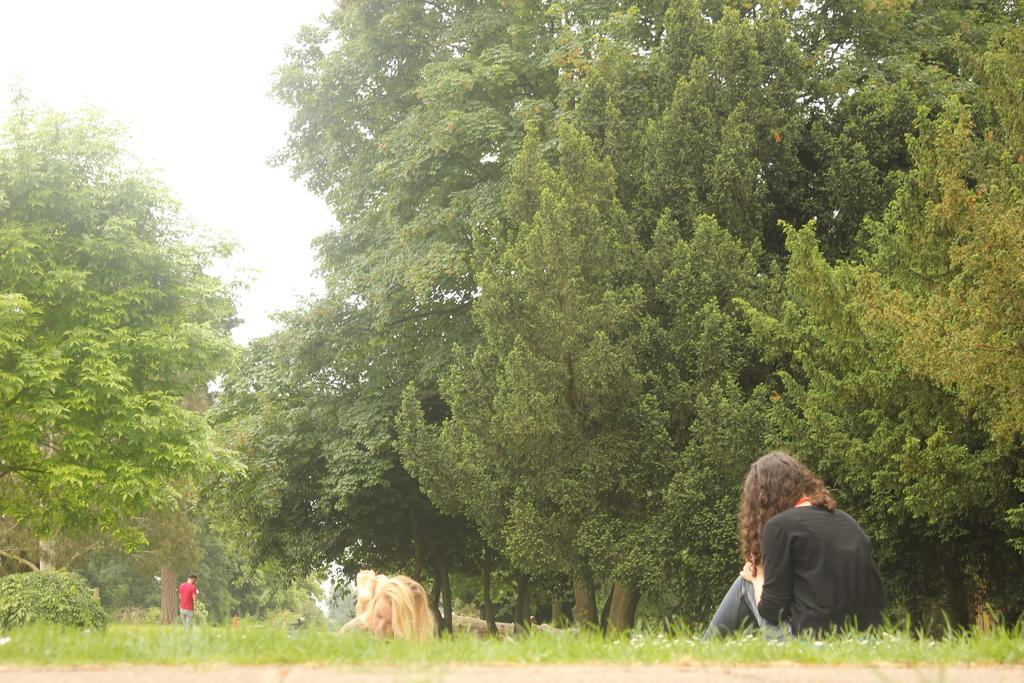How many women are in the image? There are two women in the image. Where are the women located in the image? The women are on the grass. Can you describe the clothing of one of the people in the image? There is a person wearing a red t-shirt and blue jeans in the image. What type of vegetation is visible in the image? Trees are visible in the image. What is the condition of the sky in the background of the image? The sky is clear in the background of the image. What type of garden can be seen at the end of the image? There is no garden present in the image, and the image does not have an end as it is a still photograph. 